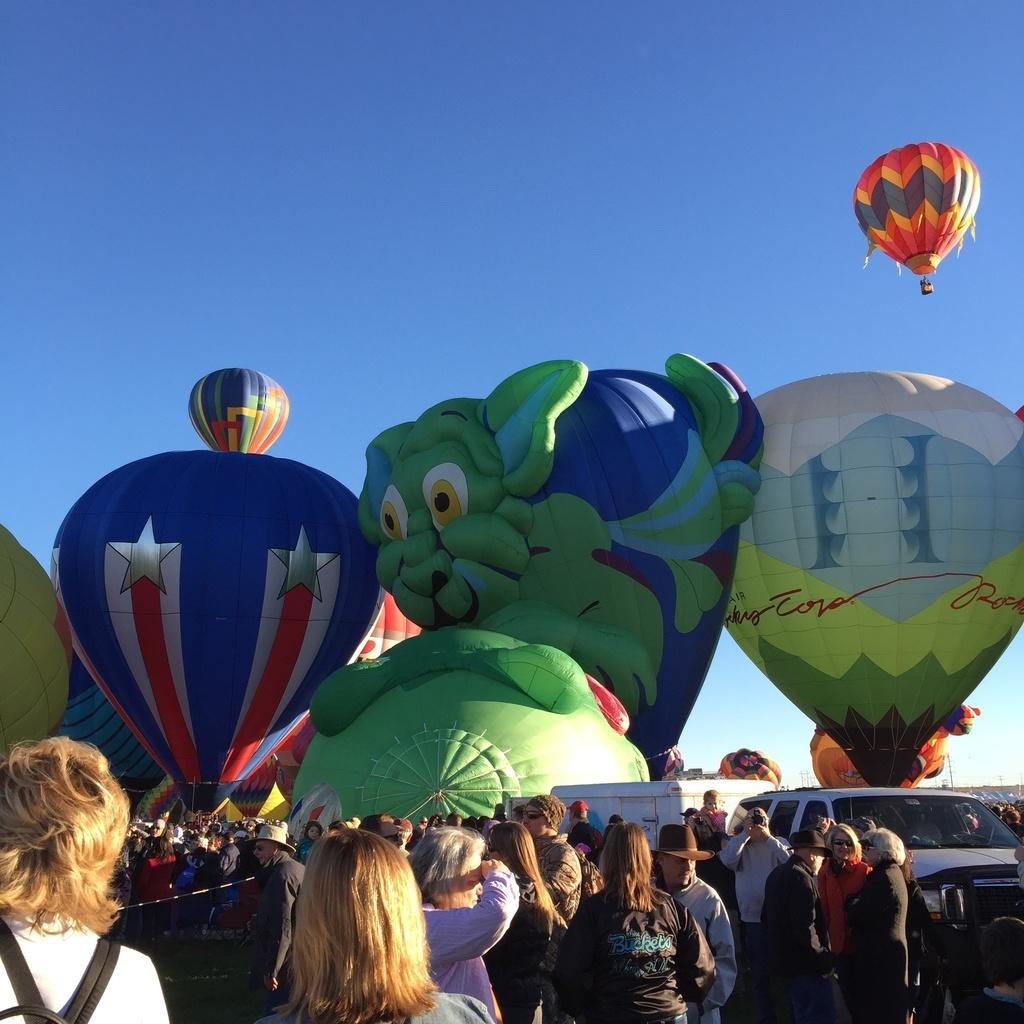Who or what can be seen at the bottom of the image? There are people at the bottom of the image. What else is present in the image besides people? There are vehicles in the image. What can be seen in the background of the image? There are air balloons in the background of the image. What is visible at the top of the image? The sky is visible at the top of the image. What type of wax is being used by the people at the bottom of the image? There is no wax present in the image; it features people, vehicles, air balloons, and the sky. Can you tell me how many sidewalks are visible in the image? There are no sidewalks visible in the image. 